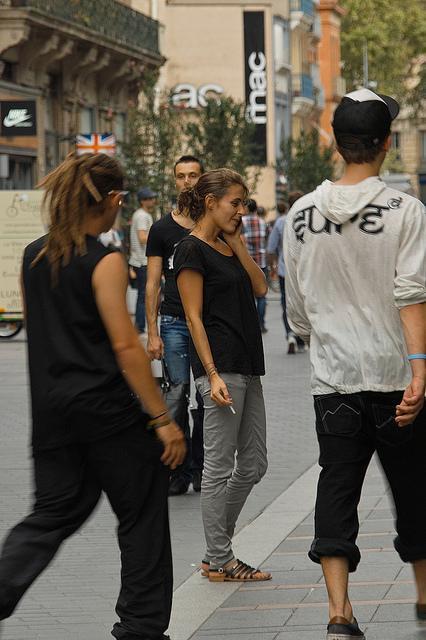How many people are there?
Give a very brief answer. 5. How many chairs in this image have visible legs?
Give a very brief answer. 0. 